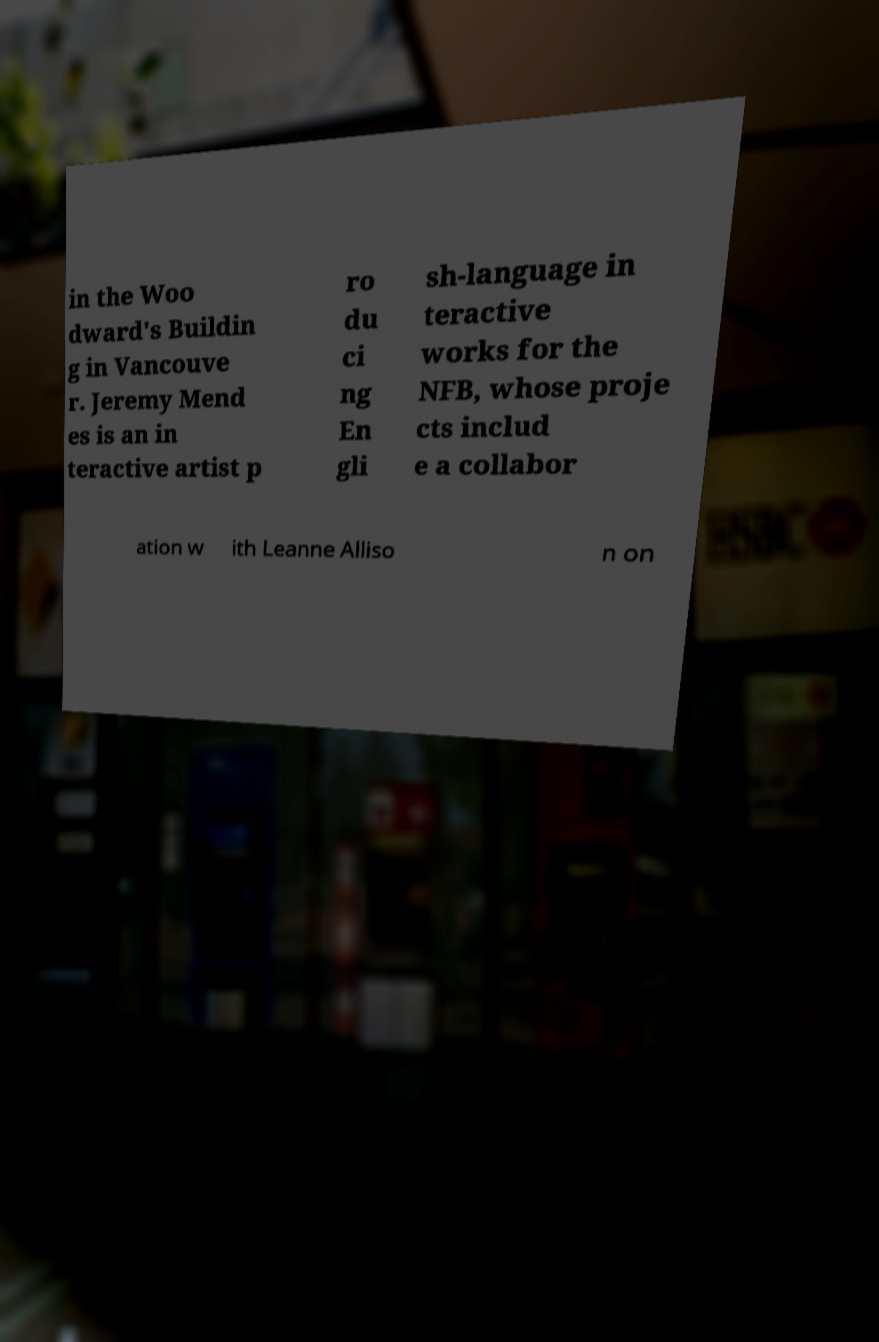Could you assist in decoding the text presented in this image and type it out clearly? in the Woo dward's Buildin g in Vancouve r. Jeremy Mend es is an in teractive artist p ro du ci ng En gli sh-language in teractive works for the NFB, whose proje cts includ e a collabor ation w ith Leanne Alliso n on 